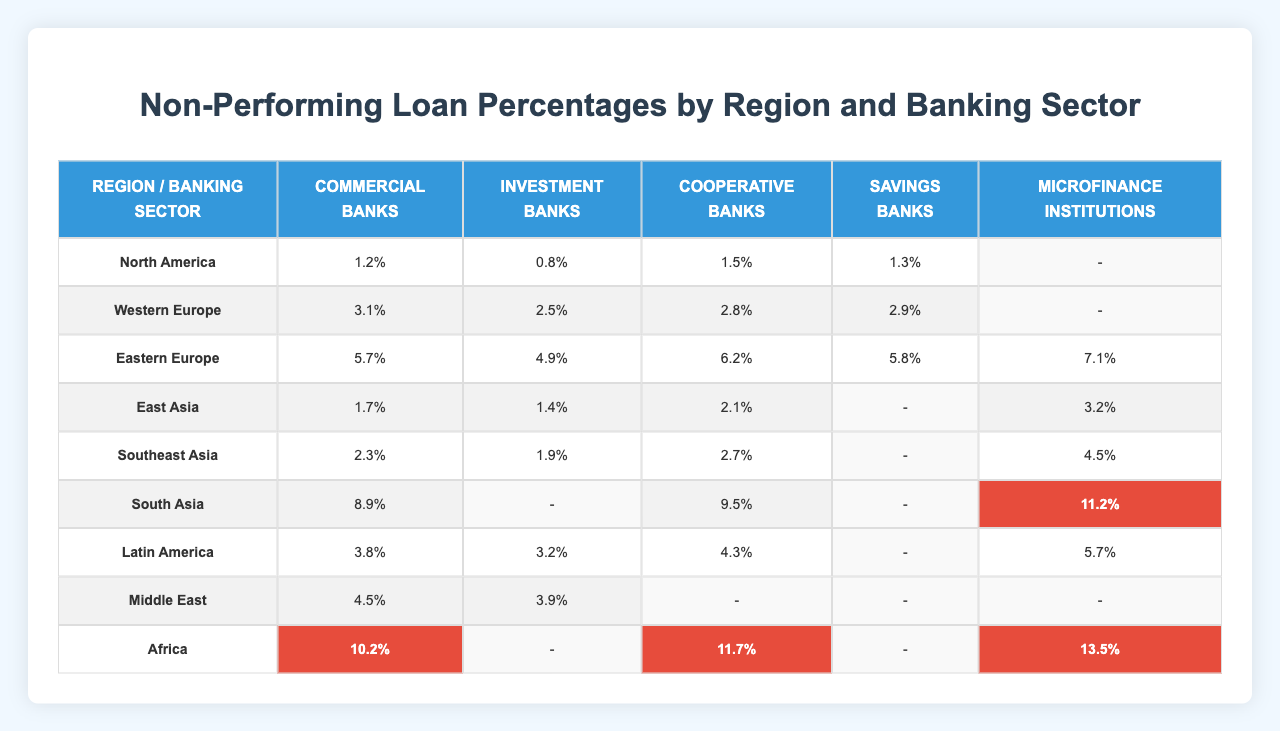What is the non-performing loan percentage for Commercial Banks in Africa? From the table, we can refer directly to the row for Africa and the column for Commercial Banks, which shows a non-performing loan percentage of 10.2%.
Answer: 10.2% Which banking sector has the highest non-performing loan percentage in South Asia? In South Asia, the banking sector with the highest non-performing loan percentage is Microfinance Institutions, which is listed as 11.2%.
Answer: Microfinance Institutions What is the average non-performing loan percentage for Investment Banks across all regions? First, we need to find the percentages for Investment Banks in each region: 0.8% (North America), 2.5% (Western Europe), 4.9% (Eastern Europe), 1.4% (East Asia), 1.9% (Southeast Asia), 3.9% (Middle East) and 3.2% (Latin America). There are 7 values, which sum to 18.5%. Dividing this by 7 gives an average of 18.5% / 7 = 2.64%.
Answer: 2.64% Is there any region where Cooperative Banks have a non-performing loan percentage above 10%? By examining the table, we can see that Cooperative Banks in Africa have a non-performing loan percentage of 11.7%. Therefore, it is true that there is a region meeting this criterion.
Answer: Yes Which region has the lowest non-performing loan percentage for Savings Banks? Looking at the Savings Banks column, we find the percentages: 1.3% (North America), 2.9% (Western Europe), 5.8% (Eastern Europe). North America has the lowest, at 1.3%.
Answer: North America What is the difference between the non-performing loan percentage of Commercial Banks in South Asia and Eastern Europe? The non-performing loan percentage for Commercial Banks in South Asia is 8.9%, while in Eastern Europe, it is 5.7%. The difference is calculated as 8.9% - 5.7% = 3.2%.
Answer: 3.2% How does the non-performing loan percentage of Microfinance Institutions in Latin America compare to that in Africa? In Latin America, Microfinance Institutions have a non-performing loan percentage of 5.7%, while in Africa, it is 13.5%. Given that 5.7% < 13.5%, it shows that Latin America's percentage is lower.
Answer: Lower Can you identify the region with the highest non-performing loan percentage for Cooperative Banks? In the table, African Cooperative Banks show the highest percentage at 11.7%, making it the region with the highest non-performing loan percentage for this sector.
Answer: Africa What are the non-performing loan percentages for Investment Banks in Western Europe and East Asia, and what is their sum? The non-performing loan percentage for Investment Banks in Western Europe is 2.5%, and in East Asia, it is 1.4%. Adding these gives us 2.5% + 1.4% = 3.9%.
Answer: 3.9% 